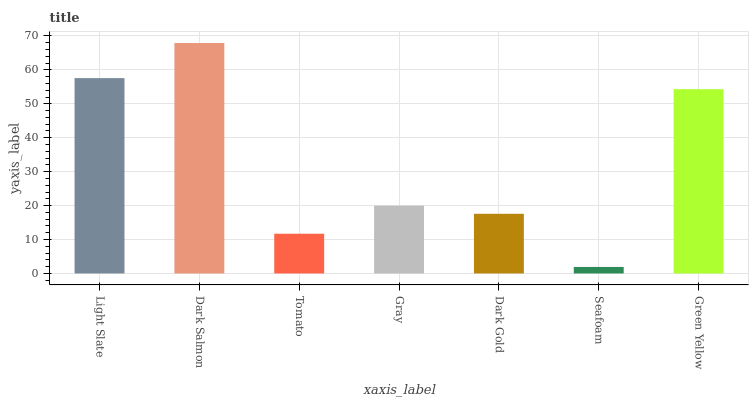Is Seafoam the minimum?
Answer yes or no. Yes. Is Dark Salmon the maximum?
Answer yes or no. Yes. Is Tomato the minimum?
Answer yes or no. No. Is Tomato the maximum?
Answer yes or no. No. Is Dark Salmon greater than Tomato?
Answer yes or no. Yes. Is Tomato less than Dark Salmon?
Answer yes or no. Yes. Is Tomato greater than Dark Salmon?
Answer yes or no. No. Is Dark Salmon less than Tomato?
Answer yes or no. No. Is Gray the high median?
Answer yes or no. Yes. Is Gray the low median?
Answer yes or no. Yes. Is Green Yellow the high median?
Answer yes or no. No. Is Tomato the low median?
Answer yes or no. No. 